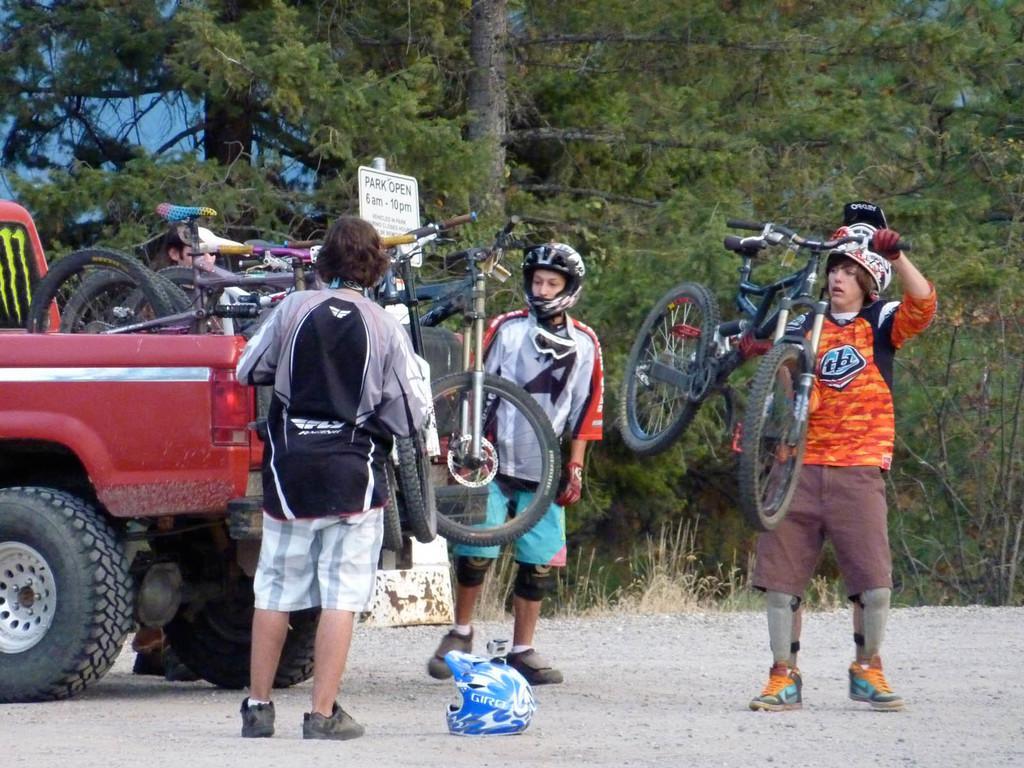Describe this image in one or two sentences. There are three people standing. This is the truck with bicycles in it. This man is holding a bicycle. I can see a helmet, which is placed on the ground. I can see a board. These are the trees with branches and leaves. I think I can see a person behind the truck. 